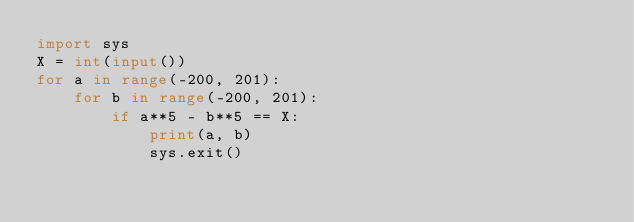<code> <loc_0><loc_0><loc_500><loc_500><_Python_>import sys
X = int(input())
for a in range(-200, 201):
    for b in range(-200, 201):
        if a**5 - b**5 == X:
            print(a, b)
            sys.exit()</code> 